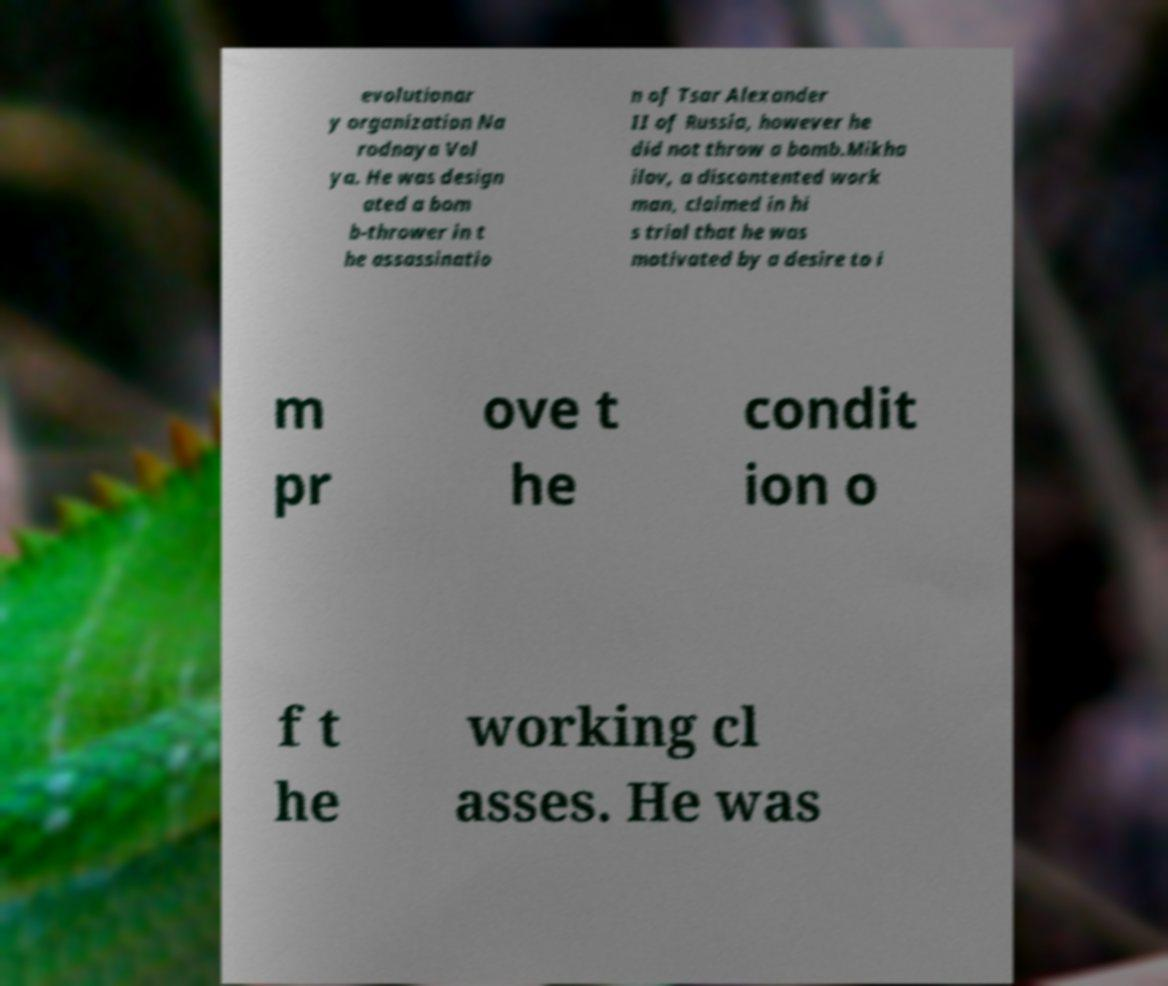Please read and relay the text visible in this image. What does it say? evolutionar y organization Na rodnaya Vol ya. He was design ated a bom b-thrower in t he assassinatio n of Tsar Alexander II of Russia, however he did not throw a bomb.Mikha ilov, a discontented work man, claimed in hi s trial that he was motivated by a desire to i m pr ove t he condit ion o f t he working cl asses. He was 